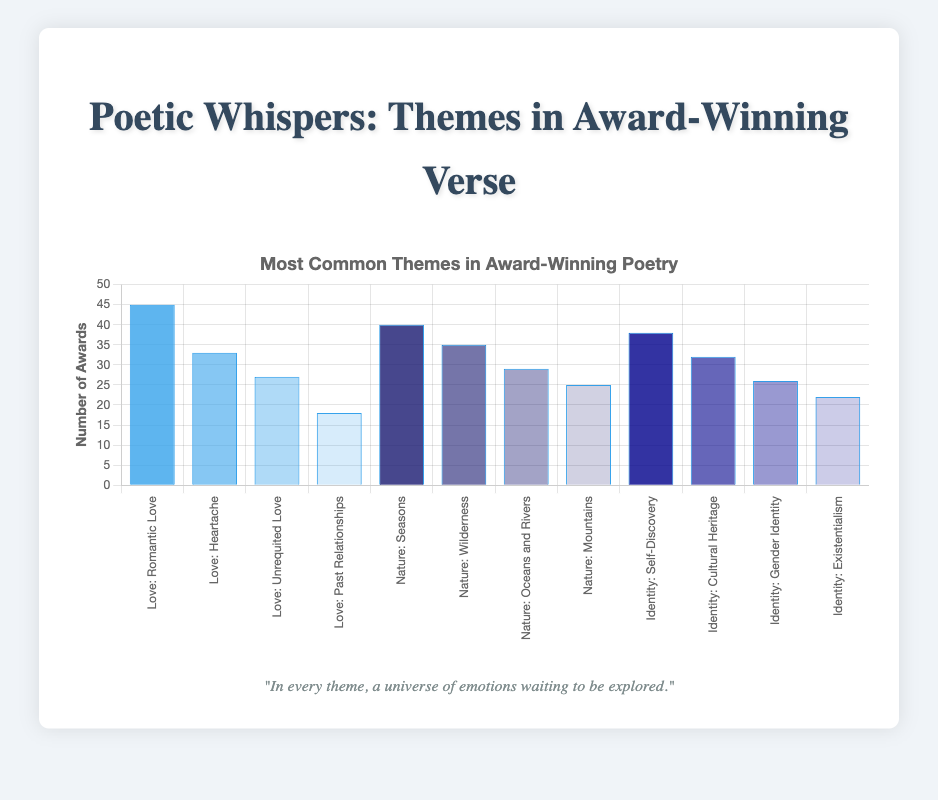Which theme has the most subthemes represented in the figure? To find this, we need to count the subthemes under each main theme in the figure. Love has 4 subthemes, Nature has 4, and Identity has 4. All have the same number of subthemes.
Answer: All themes have the same number of subthemes Which subtheme has the highest award count? Looking at the height of the bars, the tallest bar represents Romantic Love under the Love theme with 45 awards.
Answer: Romantic Love What is the total number of awards for the theme of Nature? Add up the awards for all subthemes under Nature: 40 (Seasons) + 35 (Wilderness) + 29 (Oceans and Rivers) + 25 (Mountains) = 129.
Answer: 129 Which theme has the lowest total number of awards? Calculate the total awards for each theme: Love: 45 + 33 + 27 + 18 = 123, Nature: 40 + 35 + 29 + 25 = 129, Identity: 38 + 32 + 26 + 22 = 118. Identity has the lowest total.
Answer: Identity How many more awards does the subtheme Romantic Love have compared to Gender Identity? Subtract the number of awards for Gender Identity (26) from Romantic Love (45) to find the difference: 45 - 26 = 19.
Answer: 19 What is the average number of awards for subthemes under Identity? Add the award counts for Identity's subthemes and divide by the number of subthemes: (38 + 32 + 26 + 22) / 4 = 118 / 4 = 29.5.
Answer: 29.5 How does the number of awards for Wilderness compare to that for Heartache? Wilderness has 35 awards, and Heartache has 33 awards. Therefore, Wilderness has 2 more awards than Heartache.
Answer: Wilderness has 2 more Which subtheme in Nature has the second-highest number of awards? Within the Nature theme, Oceans and Rivers has 29 awards, which is less than the 40 awards for Seasons but higher than the 25 awards for Mountains, making it the second highest after Wilderness with 35.
Answer: Wilderness What is the difference in award count between the subtheme with the highest and the one with the lowest awards? Romantic Love has the highest with 45 awards, and Past Relationships has the lowest with 18 awards, so the difference is 45 - 18 = 27.
Answer: 27 